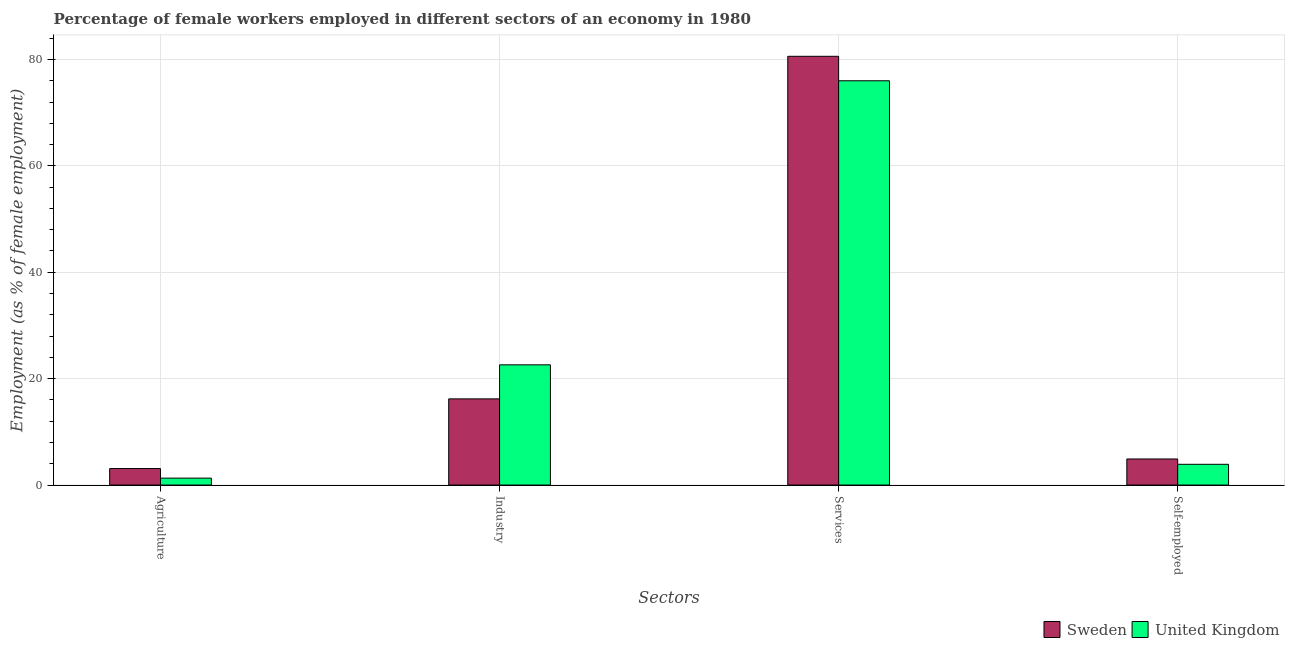How many different coloured bars are there?
Make the answer very short. 2. How many groups of bars are there?
Ensure brevity in your answer.  4. Are the number of bars per tick equal to the number of legend labels?
Offer a very short reply. Yes. How many bars are there on the 1st tick from the right?
Your response must be concise. 2. What is the label of the 4th group of bars from the left?
Your answer should be compact. Self-employed. What is the percentage of self employed female workers in Sweden?
Provide a succinct answer. 4.9. Across all countries, what is the maximum percentage of self employed female workers?
Your answer should be compact. 4.9. Across all countries, what is the minimum percentage of female workers in industry?
Provide a short and direct response. 16.2. In which country was the percentage of self employed female workers maximum?
Your answer should be compact. Sweden. In which country was the percentage of self employed female workers minimum?
Make the answer very short. United Kingdom. What is the total percentage of female workers in industry in the graph?
Make the answer very short. 38.8. What is the difference between the percentage of female workers in agriculture in Sweden and that in United Kingdom?
Provide a succinct answer. 1.8. What is the difference between the percentage of self employed female workers in United Kingdom and the percentage of female workers in agriculture in Sweden?
Make the answer very short. 0.8. What is the average percentage of female workers in services per country?
Give a very brief answer. 78.3. What is the difference between the percentage of female workers in industry and percentage of self employed female workers in United Kingdom?
Keep it short and to the point. 18.7. What is the ratio of the percentage of female workers in services in United Kingdom to that in Sweden?
Offer a terse response. 0.94. What is the difference between the highest and the lowest percentage of female workers in services?
Make the answer very short. 4.6. Is the sum of the percentage of female workers in industry in United Kingdom and Sweden greater than the maximum percentage of female workers in services across all countries?
Make the answer very short. No. What does the 1st bar from the left in Agriculture represents?
Provide a succinct answer. Sweden. Is it the case that in every country, the sum of the percentage of female workers in agriculture and percentage of female workers in industry is greater than the percentage of female workers in services?
Make the answer very short. No. Are all the bars in the graph horizontal?
Provide a succinct answer. No. How many countries are there in the graph?
Provide a succinct answer. 2. Does the graph contain any zero values?
Provide a succinct answer. No. Where does the legend appear in the graph?
Your response must be concise. Bottom right. What is the title of the graph?
Your answer should be compact. Percentage of female workers employed in different sectors of an economy in 1980. Does "Zimbabwe" appear as one of the legend labels in the graph?
Your answer should be compact. No. What is the label or title of the X-axis?
Your answer should be very brief. Sectors. What is the label or title of the Y-axis?
Offer a terse response. Employment (as % of female employment). What is the Employment (as % of female employment) in Sweden in Agriculture?
Give a very brief answer. 3.1. What is the Employment (as % of female employment) of United Kingdom in Agriculture?
Offer a very short reply. 1.3. What is the Employment (as % of female employment) in Sweden in Industry?
Make the answer very short. 16.2. What is the Employment (as % of female employment) in United Kingdom in Industry?
Offer a terse response. 22.6. What is the Employment (as % of female employment) in Sweden in Services?
Your answer should be compact. 80.6. What is the Employment (as % of female employment) in Sweden in Self-employed?
Provide a succinct answer. 4.9. What is the Employment (as % of female employment) of United Kingdom in Self-employed?
Make the answer very short. 3.9. Across all Sectors, what is the maximum Employment (as % of female employment) of Sweden?
Provide a succinct answer. 80.6. Across all Sectors, what is the minimum Employment (as % of female employment) in Sweden?
Make the answer very short. 3.1. Across all Sectors, what is the minimum Employment (as % of female employment) in United Kingdom?
Ensure brevity in your answer.  1.3. What is the total Employment (as % of female employment) in Sweden in the graph?
Keep it short and to the point. 104.8. What is the total Employment (as % of female employment) in United Kingdom in the graph?
Offer a terse response. 103.8. What is the difference between the Employment (as % of female employment) in Sweden in Agriculture and that in Industry?
Provide a succinct answer. -13.1. What is the difference between the Employment (as % of female employment) of United Kingdom in Agriculture and that in Industry?
Keep it short and to the point. -21.3. What is the difference between the Employment (as % of female employment) in Sweden in Agriculture and that in Services?
Provide a succinct answer. -77.5. What is the difference between the Employment (as % of female employment) in United Kingdom in Agriculture and that in Services?
Provide a succinct answer. -74.7. What is the difference between the Employment (as % of female employment) in Sweden in Agriculture and that in Self-employed?
Give a very brief answer. -1.8. What is the difference between the Employment (as % of female employment) in Sweden in Industry and that in Services?
Give a very brief answer. -64.4. What is the difference between the Employment (as % of female employment) in United Kingdom in Industry and that in Services?
Offer a terse response. -53.4. What is the difference between the Employment (as % of female employment) of United Kingdom in Industry and that in Self-employed?
Offer a very short reply. 18.7. What is the difference between the Employment (as % of female employment) in Sweden in Services and that in Self-employed?
Give a very brief answer. 75.7. What is the difference between the Employment (as % of female employment) in United Kingdom in Services and that in Self-employed?
Your answer should be compact. 72.1. What is the difference between the Employment (as % of female employment) in Sweden in Agriculture and the Employment (as % of female employment) in United Kingdom in Industry?
Ensure brevity in your answer.  -19.5. What is the difference between the Employment (as % of female employment) in Sweden in Agriculture and the Employment (as % of female employment) in United Kingdom in Services?
Your answer should be compact. -72.9. What is the difference between the Employment (as % of female employment) of Sweden in Industry and the Employment (as % of female employment) of United Kingdom in Services?
Provide a succinct answer. -59.8. What is the difference between the Employment (as % of female employment) of Sweden in Services and the Employment (as % of female employment) of United Kingdom in Self-employed?
Keep it short and to the point. 76.7. What is the average Employment (as % of female employment) of Sweden per Sectors?
Your answer should be compact. 26.2. What is the average Employment (as % of female employment) in United Kingdom per Sectors?
Provide a succinct answer. 25.95. What is the difference between the Employment (as % of female employment) of Sweden and Employment (as % of female employment) of United Kingdom in Services?
Give a very brief answer. 4.6. What is the ratio of the Employment (as % of female employment) of Sweden in Agriculture to that in Industry?
Your answer should be compact. 0.19. What is the ratio of the Employment (as % of female employment) in United Kingdom in Agriculture to that in Industry?
Offer a very short reply. 0.06. What is the ratio of the Employment (as % of female employment) of Sweden in Agriculture to that in Services?
Offer a very short reply. 0.04. What is the ratio of the Employment (as % of female employment) of United Kingdom in Agriculture to that in Services?
Offer a terse response. 0.02. What is the ratio of the Employment (as % of female employment) in Sweden in Agriculture to that in Self-employed?
Your response must be concise. 0.63. What is the ratio of the Employment (as % of female employment) in Sweden in Industry to that in Services?
Your answer should be very brief. 0.2. What is the ratio of the Employment (as % of female employment) of United Kingdom in Industry to that in Services?
Your answer should be very brief. 0.3. What is the ratio of the Employment (as % of female employment) of Sweden in Industry to that in Self-employed?
Provide a succinct answer. 3.31. What is the ratio of the Employment (as % of female employment) of United Kingdom in Industry to that in Self-employed?
Offer a very short reply. 5.79. What is the ratio of the Employment (as % of female employment) of Sweden in Services to that in Self-employed?
Your answer should be compact. 16.45. What is the ratio of the Employment (as % of female employment) of United Kingdom in Services to that in Self-employed?
Provide a succinct answer. 19.49. What is the difference between the highest and the second highest Employment (as % of female employment) of Sweden?
Make the answer very short. 64.4. What is the difference between the highest and the second highest Employment (as % of female employment) of United Kingdom?
Offer a very short reply. 53.4. What is the difference between the highest and the lowest Employment (as % of female employment) in Sweden?
Provide a short and direct response. 77.5. What is the difference between the highest and the lowest Employment (as % of female employment) of United Kingdom?
Your answer should be very brief. 74.7. 